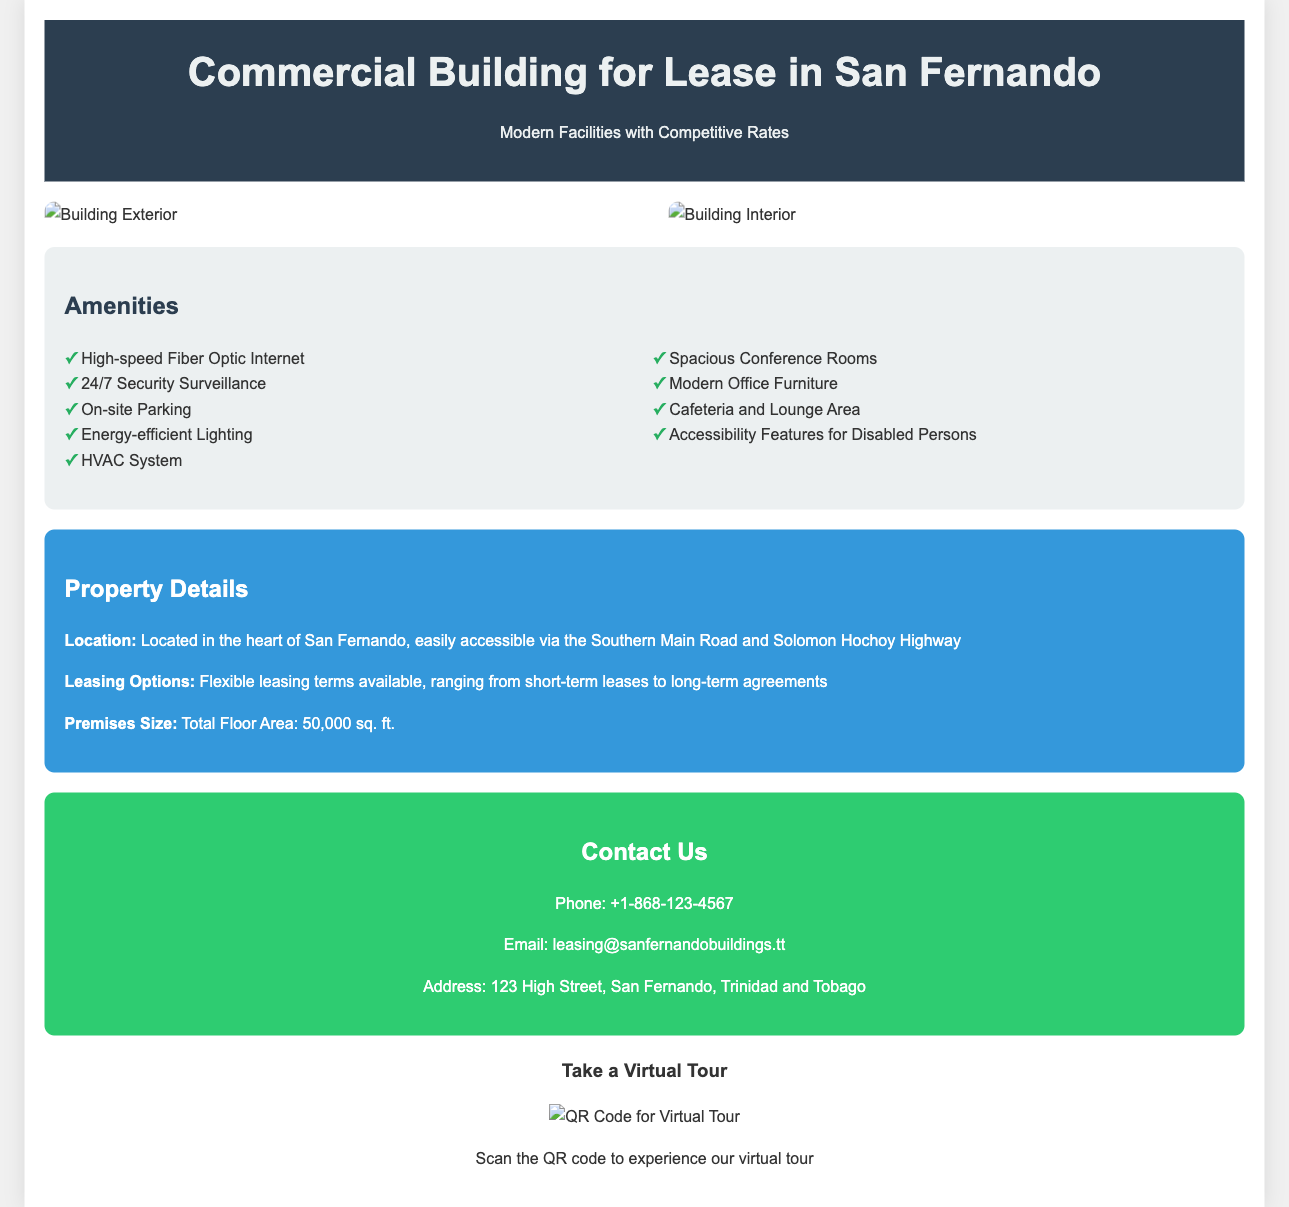What is the total floor area of the building? The total floor area is specified in the Property Details section of the document.
Answer: 50,000 sq. ft What are the leasing options available? The leasing options are mentioned in the Property Details section of the document.
Answer: Flexible leasing terms What amenities are available in the building? The amenities are listed in the Amenities section of the document.
Answer: High-speed Fiber Optic Internet Where is the property located? The location of the property is provided in the Property Details section of the document.
Answer: Heart of San Fernando What is the contact phone number? The contact phone number is found in the Contact Us section of the document.
Answer: +1-868-123-4567 How can a visitor take a virtual tour? The method for taking a virtual tour is specified in the QR Code section of the document.
Answer: Scan the QR code What feature an on-site facility provides? The on-site facility features are listed in the Amenities section.
Answer: Cafeteria and Lounge Area What type of surveillance is provided for security? The type of surveillance is mentioned in the Amenities section of the document.
Answer: 24/7 Security Surveillance What color is the header background? The color of the header background is described in the stylesheet part of the document.
Answer: #2c3e50 